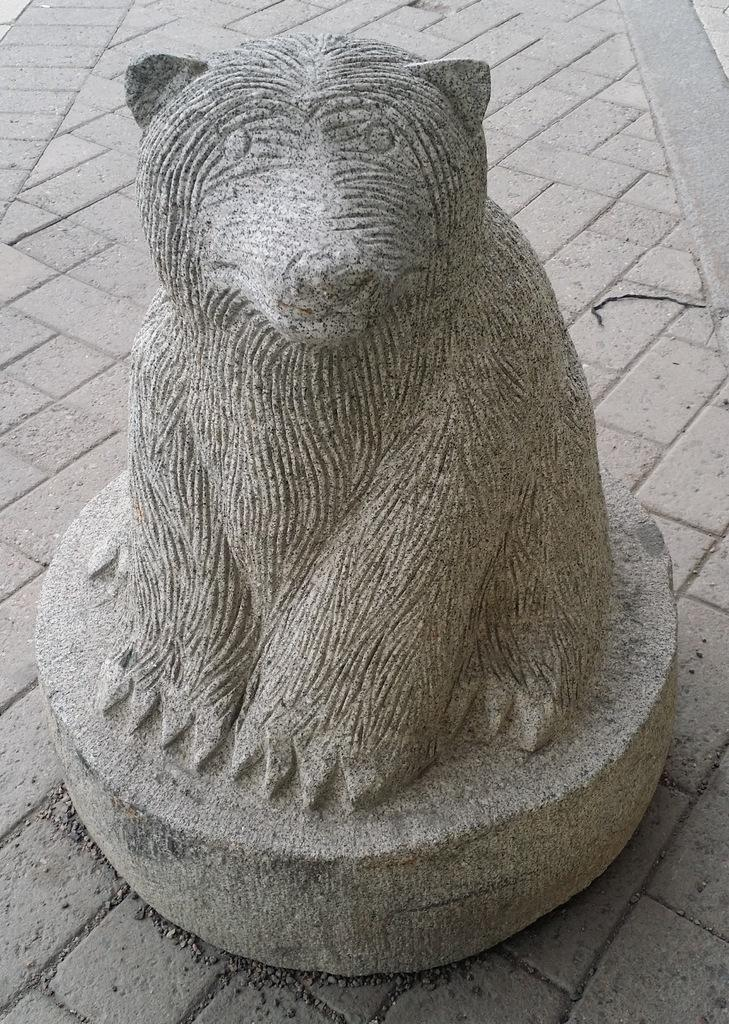What is the main subject of the image? There is a statue of an animal in the image. What color is the statue? The statue is gray in color. What else can be seen in the image besides the statue? There is a footpath in the image. Reasoning: Let' Let's think step by step in order to produce the conversation. We start by identifying the main subject of the image, which is the statue of an animal. Then, we describe the color of the statue, which is gray. Finally, we mention the presence of a footpath in the image, which provides additional context about the setting. Absurd Question/Answer: What decision was made by the statue in the image? There is no decision made by the statue in the image, as it is a statue and not a living being capable of making decisions. 